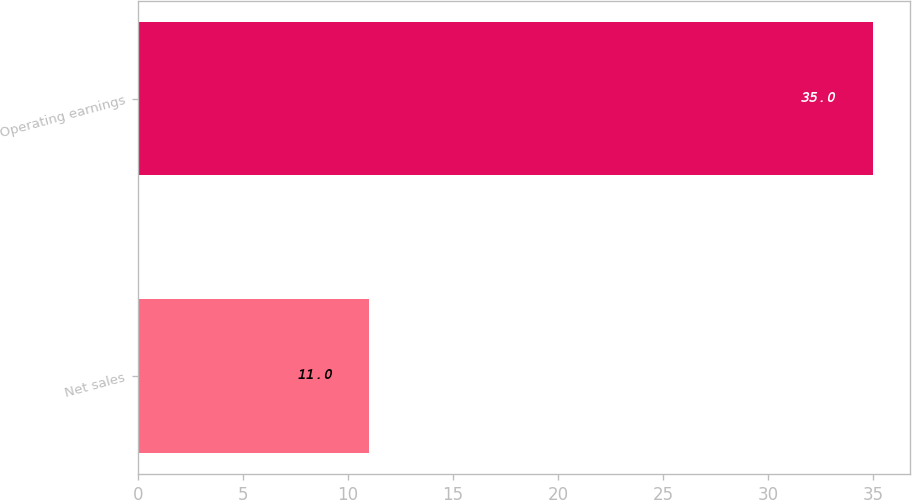<chart> <loc_0><loc_0><loc_500><loc_500><bar_chart><fcel>Net sales<fcel>Operating earnings<nl><fcel>11<fcel>35<nl></chart> 